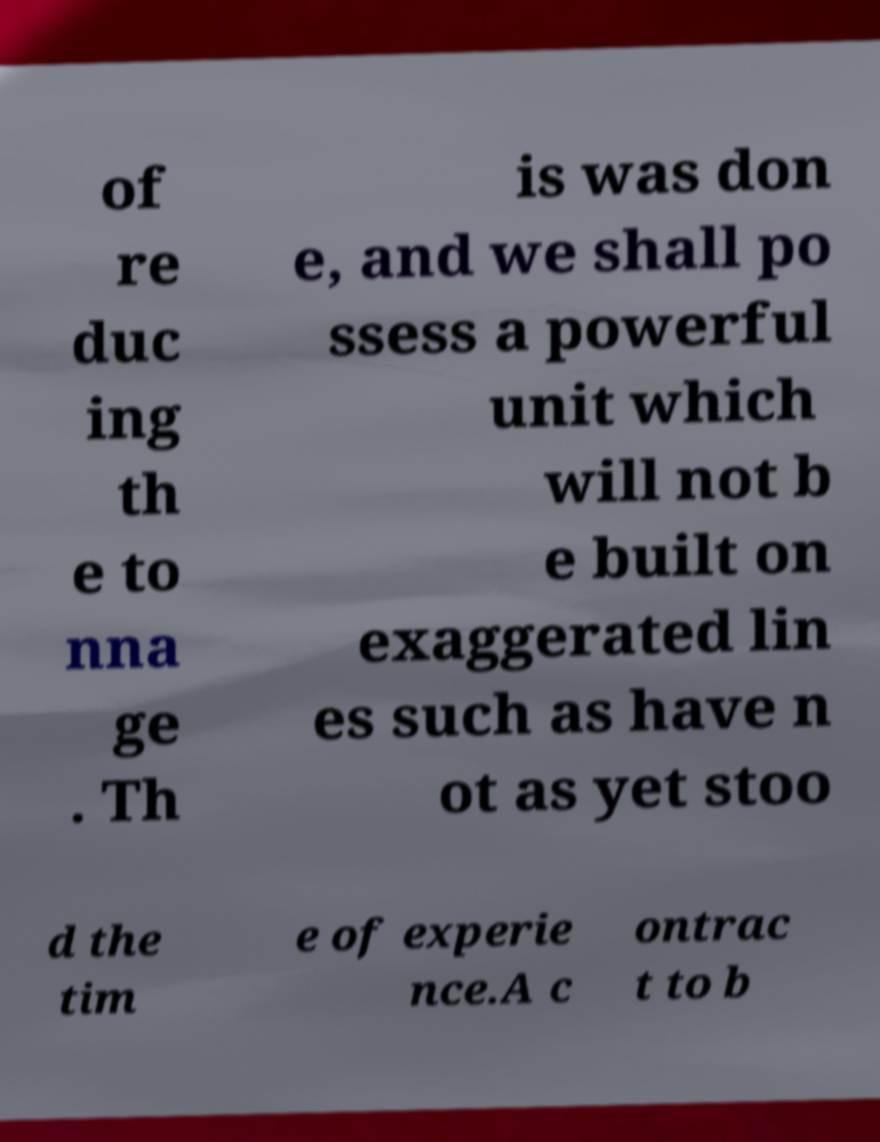Could you assist in decoding the text presented in this image and type it out clearly? of re duc ing th e to nna ge . Th is was don e, and we shall po ssess a powerful unit which will not b e built on exaggerated lin es such as have n ot as yet stoo d the tim e of experie nce.A c ontrac t to b 